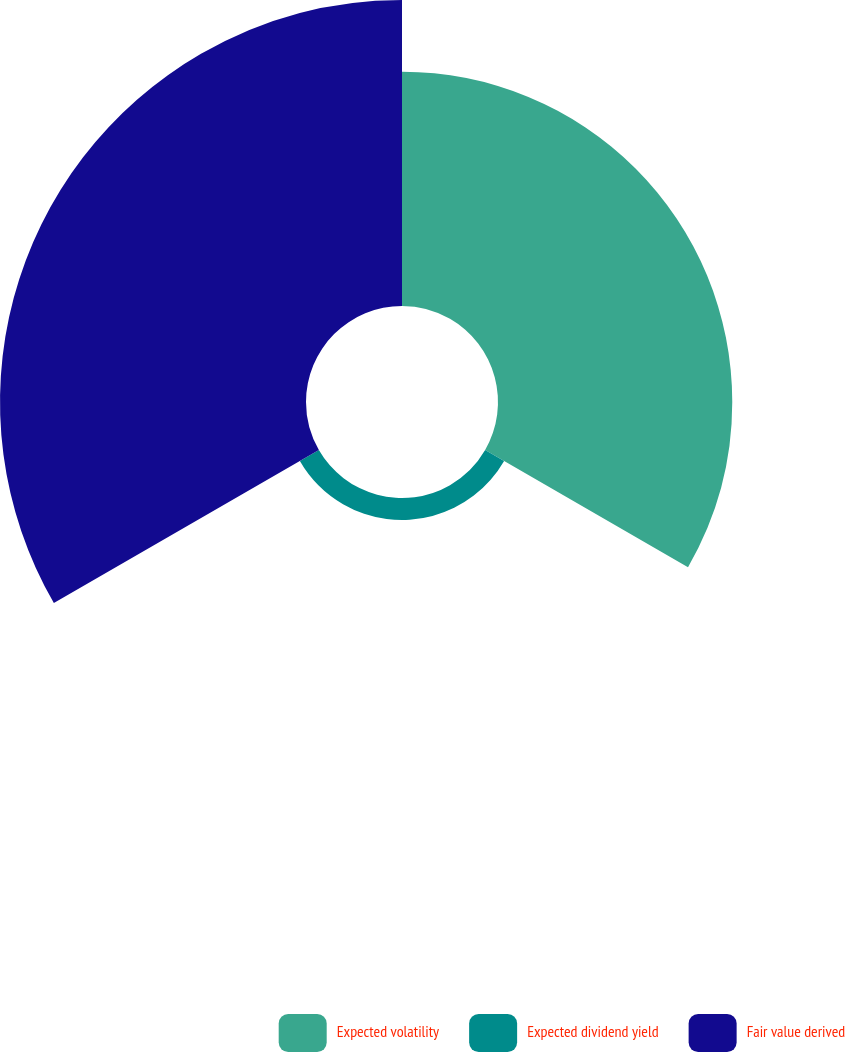Convert chart. <chart><loc_0><loc_0><loc_500><loc_500><pie_chart><fcel>Expected volatility<fcel>Expected dividend yield<fcel>Fair value derived<nl><fcel>41.67%<fcel>3.9%<fcel>54.43%<nl></chart> 